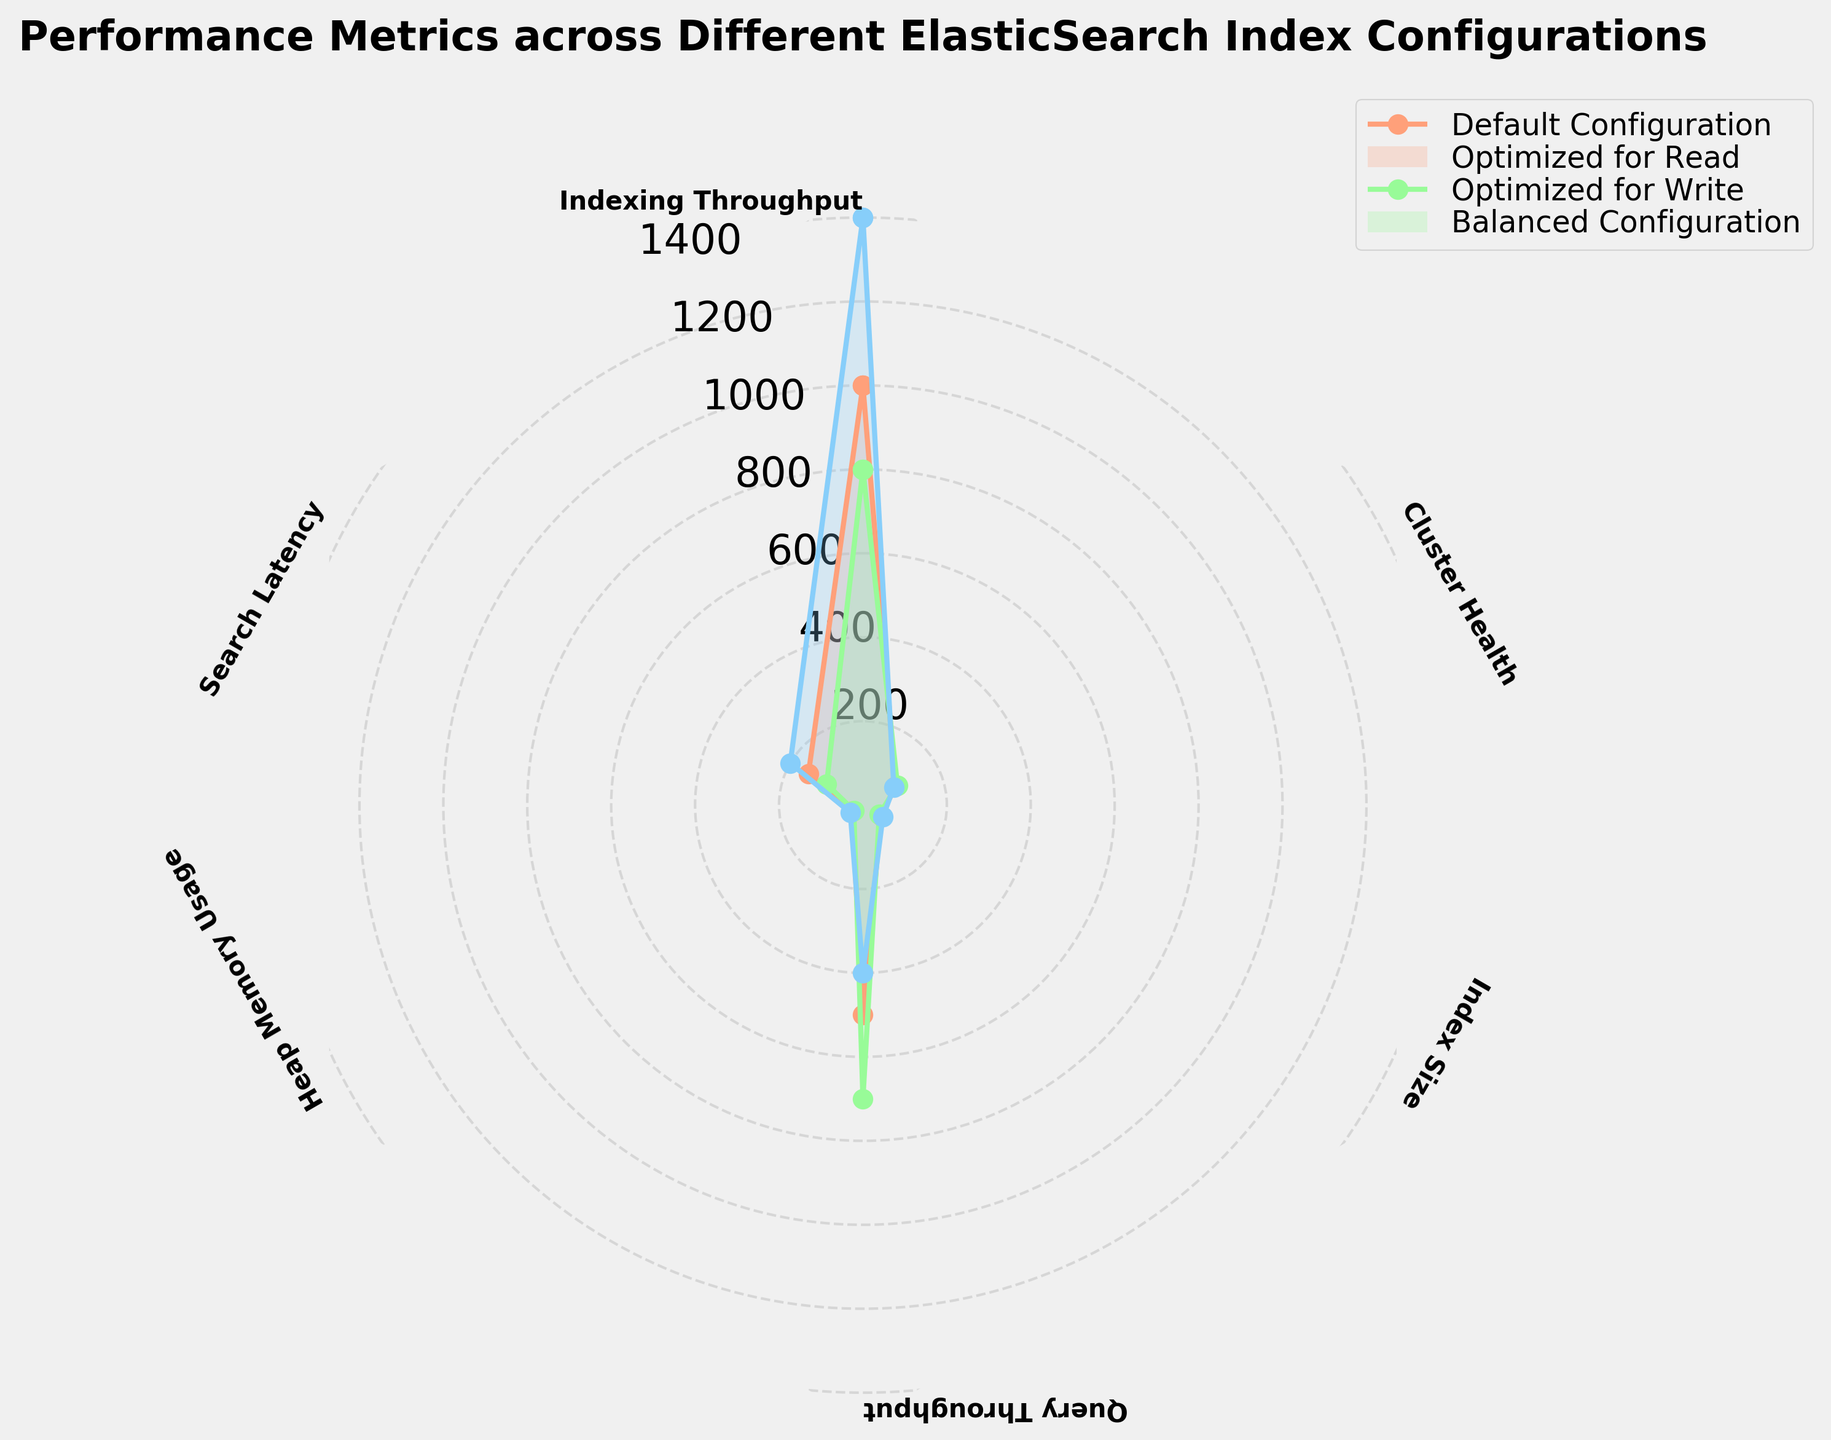What is the title of the radar chart? The title of the radar chart is usually placed at the top of the plot and provides an overview of what the chart represents. In this case, the title mentions that the chart compares different ElasticSearch index configurations across various performance metrics.
Answer: Performance Metrics across Different ElasticSearch Index Configurations Which index configuration has the highest indexing throughput? To find the configuration with the highest indexing throughput, look for the one with the longest spoke on the 'Indexing Throughput' axis. The 'Optimized for Write' configuration has the highest value at 1400.
Answer: Optimized for Write How does the 'Balanced Configuration' compare to the 'Default Configuration' in terms of search latency? The search latency for both configurations can be compared by looking at their respective values on the 'Search Latency' axis. The 'Balanced Configuration' has a search latency of 125, whereas the 'Default Configuration' has a search latency of 150. Hence, the 'Balanced Configuration' has a lower (better) search latency.
Answer: Balanced Configuration has lower search latency Which configuration uses the least heap memory? To determine the configuration with the least heap memory usage, look at the values on the 'Heap Memory Usage' axis. The 'Optimized for Read' configuration has the least heap memory usage at 25.
Answer: Optimized for Read Rank the configurations in terms of query throughput from highest to lowest. Check the values on the 'Query Throughput' axis for each configuration. The 'Optimized for Read' configuration has the highest throughput (700), followed by 'Balanced Configuration' (600), 'Default Configuration' (500), and lastly, 'Optimized for Write' (400).
Answer: Optimized for Read, Balanced Configuration, Default Configuration, Optimized for Write Which configuration maintains the healthiest cluster? The cluster health values are plotted on the 'Cluster Health' axis. The 'Optimized for Read' configuration has the highest cluster health value at 95.
Answer: Optimized for Read What's the difference in indexing throughput between the 'Default Configuration' and the 'Balanced Configuration'? Find the indexing throughput values for both configurations on their respective axis. The 'Default Configuration' has 1000 and the 'Balanced Configuration' has 1200. The difference is 1200 - 1000 = 200.
Answer: 200 What is the average index size across all configurations? To find the average index size, sum the values for all configurations and divide by the number of configurations. The values are 50, 45, 55, and 48. The sum is 198, and the average is 198 / 4 = 49.5.
Answer: 49.5 